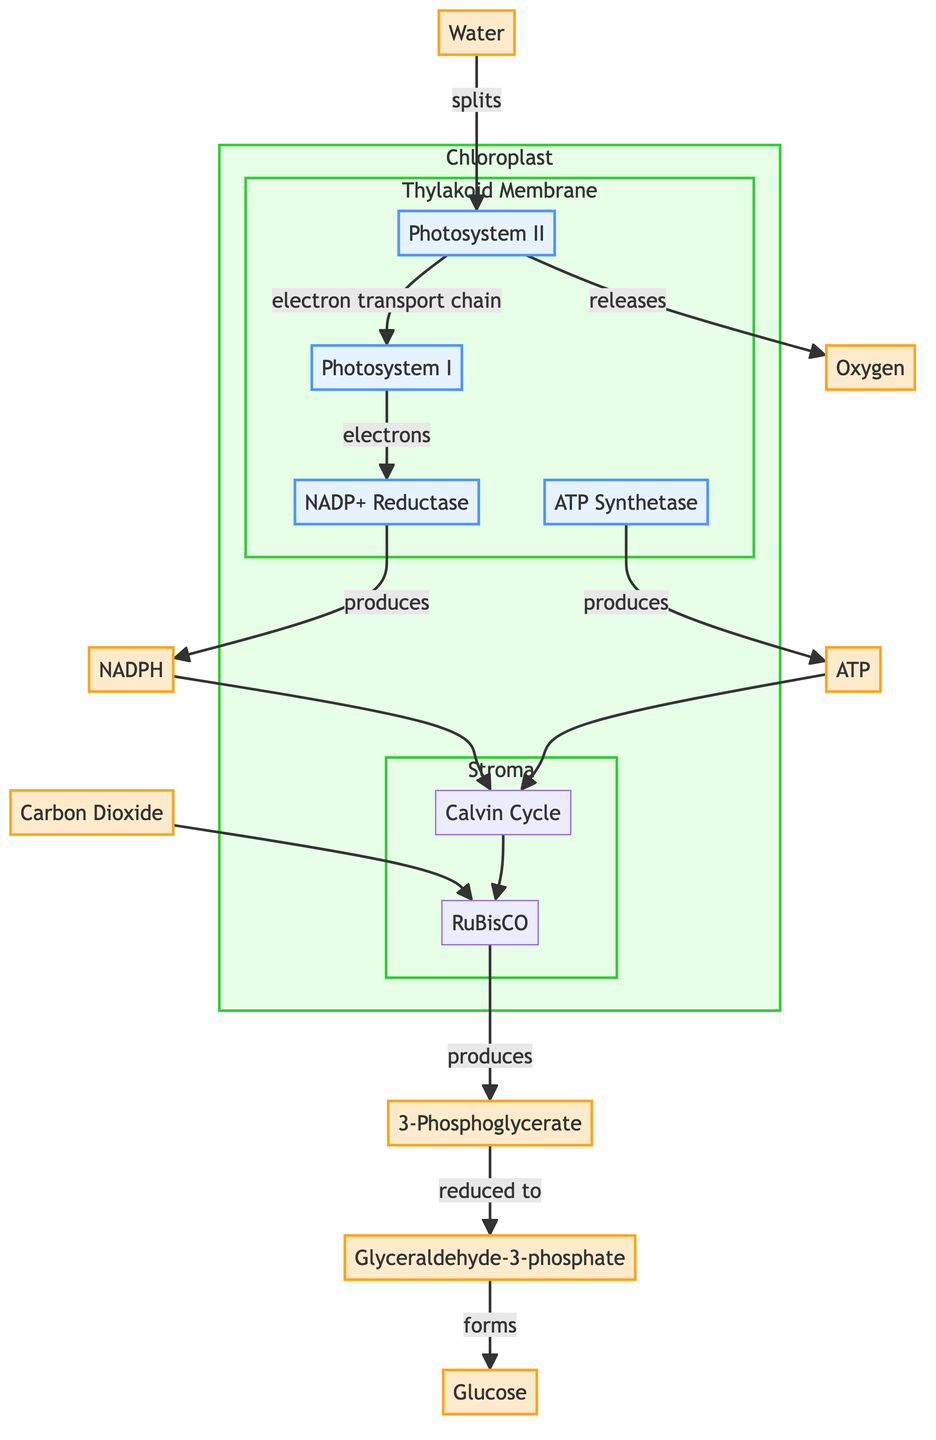What is the source of electrons for Photosystem II? In the diagram, the source of electrons for Photosystem II is labeled as Water (H2O), which splits to provide the necessary electrons.
Answer: Water How is oxygen produced in this process? Oxygen is released as a byproduct when water (H2O) splits at Photosystem II. This flow indicates that the splitting of water generates oxygen gas.
Answer: Oxygen What is produced by the reduction of 3-Phosphoglycerate (PGA)? The diagram shows that 3-Phosphoglycerate (PGA) is reduced to Glyceraldehyde-3-phosphate (G3P), indicating this transformation in the biochemical pathway.
Answer: Glyceraldehyde-3-phosphate Which enzyme is responsible for the carbon fixation process? Carbon fixation in the diagram is attributed to the enzyme RuBisCO, which converts carbon dioxide into 3-Phosphoglycerate (PGA).
Answer: RuBisCO How many distinct compartments are shown in the chloroplast? The diagram displays two separate compartments: the Thylakoid Membrane and the Stroma, illustrating their roles in the photosynthesis process.
Answer: Two What molecules are required for the Calvin Cycle to occur? According to the diagram, the Calvin Cycle requires both NADPH and ATP, which are produced during the light-dependent reactions and utilized in the light-independent reactions.
Answer: NADPH and ATP Which process is depicted to occur in the Thylakoid Membrane? The diagram clearly indicates that the light-dependent reactions of photosynthesis occur in the Thylakoid Membrane, involving the processes surrounding Photosystem II and Photosystem I.
Answer: Light-dependent reactions How is glucose formed in this process? The diagram explains that glucose is formed from Glyceraldehyde-3-phosphate (G3P) during the Calvin Cycle, demonstrating the conversion from a simpler molecule to a carbohydrate.
Answer: Glucose What molecules form when NADP+ is reduced? The diagram illustrates that the reduction of NADP+ takes place at NADP+ Reductase, leading to the production of NADPH.
Answer: NADPH 